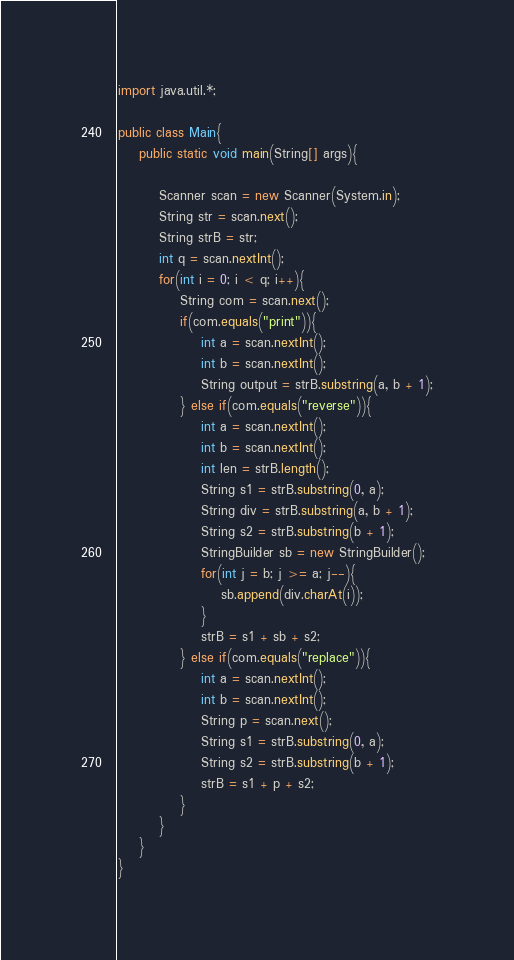<code> <loc_0><loc_0><loc_500><loc_500><_Java_>import java.util.*;

public class Main{
	public static void main(String[] args){

		Scanner scan = new Scanner(System.in);
		String str = scan.next();
		String strB = str;
		int q = scan.nextInt();
		for(int i = 0; i < q; i++){
			String com = scan.next();
			if(com.equals("print")){
				int a = scan.nextInt();
				int b = scan.nextInt();
				String output = strB.substring(a, b + 1);
			} else if(com.equals("reverse")){
				int a = scan.nextInt();
				int b = scan.nextInt();
				int len = strB.length();
				String s1 = strB.substring(0, a);
				String div = strB.substring(a, b + 1);
				String s2 = strB.substring(b + 1);
				StringBuilder sb = new StringBuilder();
				for(int j = b; j >= a; j--){
					sb.append(div.charAt(i));
				}
				strB = s1 + sb + s2;
			} else if(com.equals("replace")){
				int a = scan.nextInt();
				int b = scan.nextInt();
				String p = scan.next();
				String s1 = strB.substring(0, a);
				String s2 = strB.substring(b + 1);
				strB = s1 + p + s2;
			}
		}
	}
}</code> 